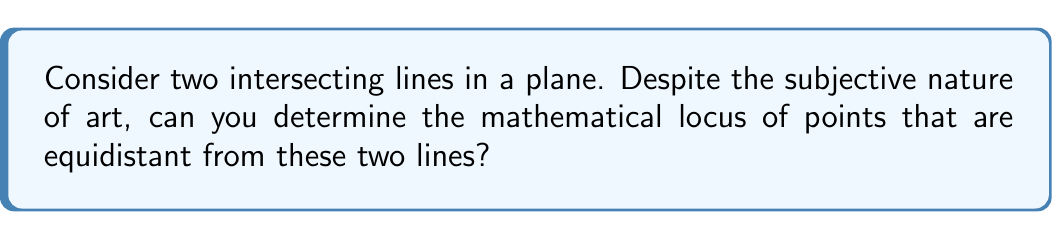Show me your answer to this math problem. Let's approach this step-by-step:

1) First, let's visualize the problem:

[asy]
import geometry;

size(200);
pair O=(0,0);
draw((-2,-2)--(2,2));
draw((-2,2)--(2,-2));
dot(O);
label("O", O, SE);
draw(circle(O,1), dashed);
pair P = (0.7,0.7);
dot(P);
label("P", P, NE);
draw(O--P);
[/asy]

2) Let the two lines be $l_1$ and $l_2$, intersecting at point O.

3) Let P be any point equidistant from both lines.

4) The distance from a point to a line is the length of the perpendicular from the point to the line.

5) Let the angle between the lines be $2\theta$. Then, the angle between each line and the angle bisector is $\theta$.

6) Consider the right triangle formed by P, its projection on one of the lines, and O:

   $$\tan \theta = \frac{PQ}{OQ}$$

   where Q is the projection of P on either line.

7) This equation holds true for any point P equidistant from both lines.

8) This is the equation of a straight line passing through O.

9) In fact, there are two such lines: the angle bisectors of the angles formed by the intersecting lines.

10) These angle bisectors are perpendicular to each other, forming two lines that intersect at O and make equal angles with $l_1$ and $l_2$.
Answer: The locus is two perpendicular lines bisecting the angles formed by the given intersecting lines. 